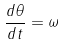<formula> <loc_0><loc_0><loc_500><loc_500>\frac { d \theta } { d t } = \omega</formula> 